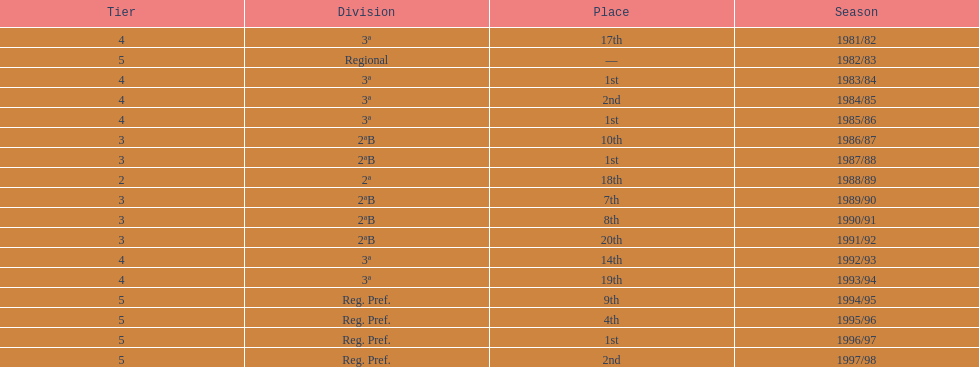When is the last year that the team has been division 2? 1991/92. 